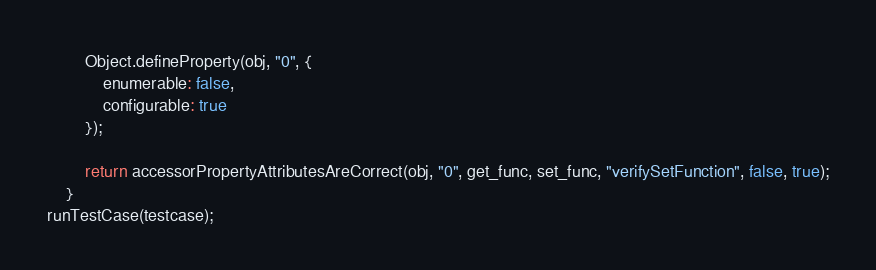Convert code to text. <code><loc_0><loc_0><loc_500><loc_500><_JavaScript_>
        Object.defineProperty(obj, "0", {
            enumerable: false,
            configurable: true
        });

        return accessorPropertyAttributesAreCorrect(obj, "0", get_func, set_func, "verifySetFunction", false, true);
    }
runTestCase(testcase);
</code> 